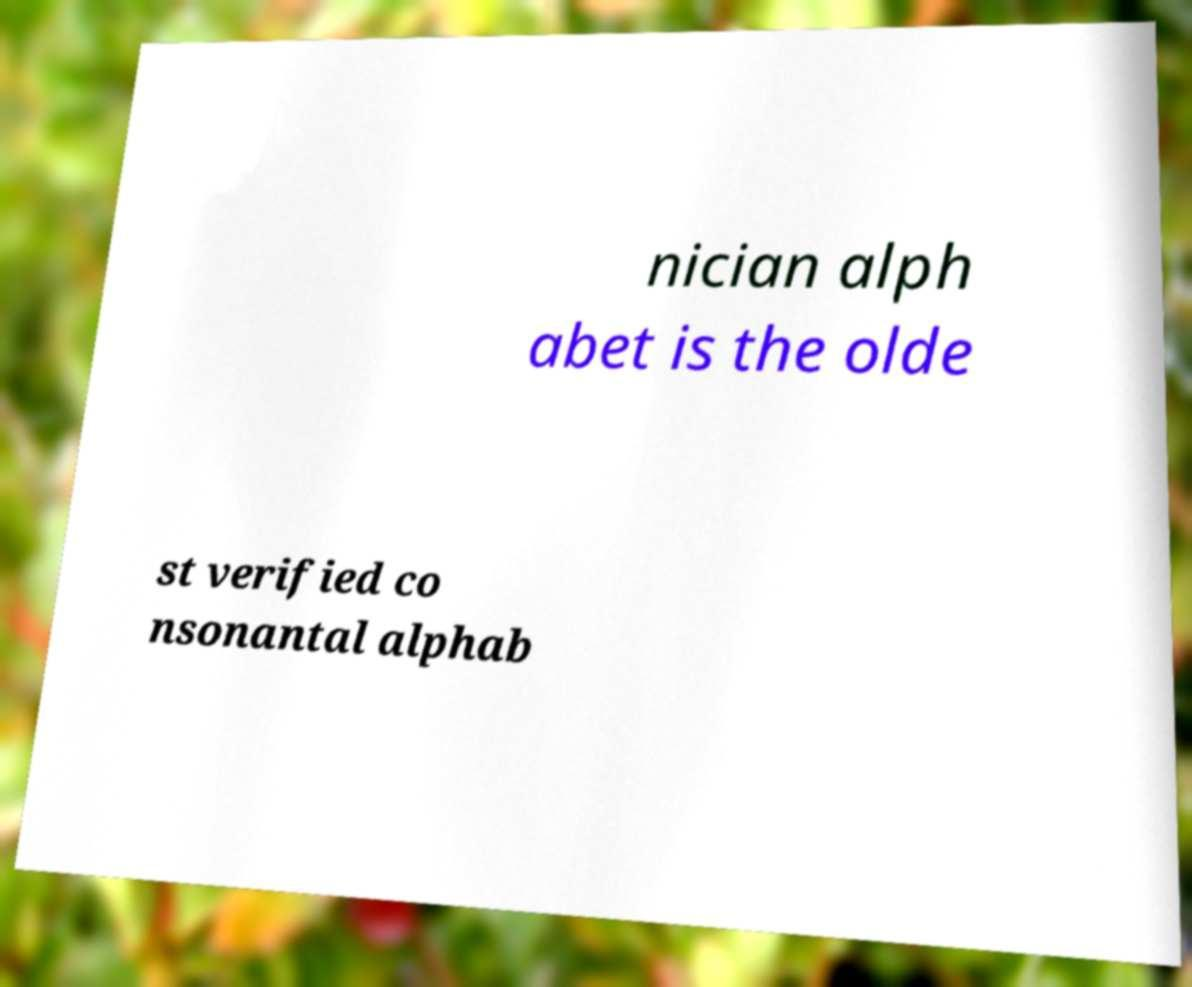Can you read and provide the text displayed in the image?This photo seems to have some interesting text. Can you extract and type it out for me? nician alph abet is the olde st verified co nsonantal alphab 